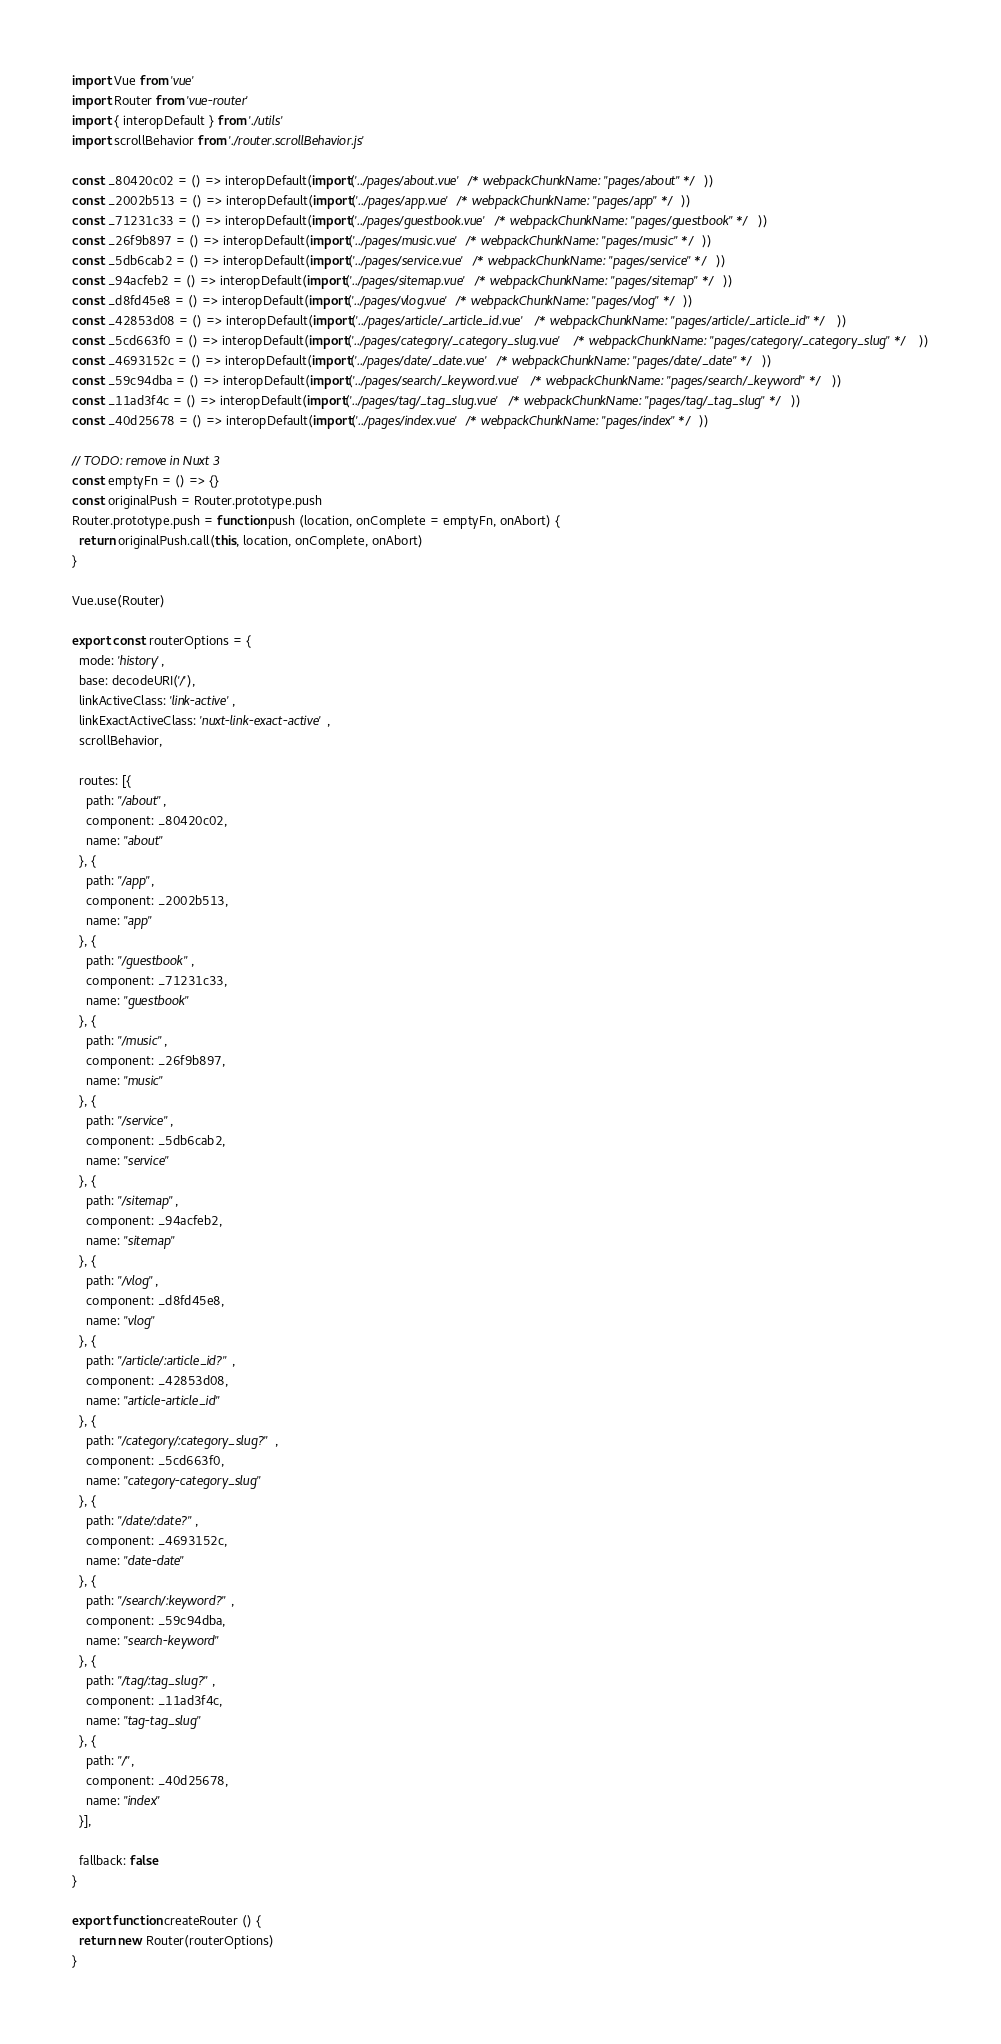Convert code to text. <code><loc_0><loc_0><loc_500><loc_500><_JavaScript_>import Vue from 'vue'
import Router from 'vue-router'
import { interopDefault } from './utils'
import scrollBehavior from './router.scrollBehavior.js'

const _80420c02 = () => interopDefault(import('../pages/about.vue' /* webpackChunkName: "pages/about" */))
const _2002b513 = () => interopDefault(import('../pages/app.vue' /* webpackChunkName: "pages/app" */))
const _71231c33 = () => interopDefault(import('../pages/guestbook.vue' /* webpackChunkName: "pages/guestbook" */))
const _26f9b897 = () => interopDefault(import('../pages/music.vue' /* webpackChunkName: "pages/music" */))
const _5db6cab2 = () => interopDefault(import('../pages/service.vue' /* webpackChunkName: "pages/service" */))
const _94acfeb2 = () => interopDefault(import('../pages/sitemap.vue' /* webpackChunkName: "pages/sitemap" */))
const _d8fd45e8 = () => interopDefault(import('../pages/vlog.vue' /* webpackChunkName: "pages/vlog" */))
const _42853d08 = () => interopDefault(import('../pages/article/_article_id.vue' /* webpackChunkName: "pages/article/_article_id" */))
const _5cd663f0 = () => interopDefault(import('../pages/category/_category_slug.vue' /* webpackChunkName: "pages/category/_category_slug" */))
const _4693152c = () => interopDefault(import('../pages/date/_date.vue' /* webpackChunkName: "pages/date/_date" */))
const _59c94dba = () => interopDefault(import('../pages/search/_keyword.vue' /* webpackChunkName: "pages/search/_keyword" */))
const _11ad3f4c = () => interopDefault(import('../pages/tag/_tag_slug.vue' /* webpackChunkName: "pages/tag/_tag_slug" */))
const _40d25678 = () => interopDefault(import('../pages/index.vue' /* webpackChunkName: "pages/index" */))

// TODO: remove in Nuxt 3
const emptyFn = () => {}
const originalPush = Router.prototype.push
Router.prototype.push = function push (location, onComplete = emptyFn, onAbort) {
  return originalPush.call(this, location, onComplete, onAbort)
}

Vue.use(Router)

export const routerOptions = {
  mode: 'history',
  base: decodeURI('/'),
  linkActiveClass: 'link-active',
  linkExactActiveClass: 'nuxt-link-exact-active',
  scrollBehavior,

  routes: [{
    path: "/about",
    component: _80420c02,
    name: "about"
  }, {
    path: "/app",
    component: _2002b513,
    name: "app"
  }, {
    path: "/guestbook",
    component: _71231c33,
    name: "guestbook"
  }, {
    path: "/music",
    component: _26f9b897,
    name: "music"
  }, {
    path: "/service",
    component: _5db6cab2,
    name: "service"
  }, {
    path: "/sitemap",
    component: _94acfeb2,
    name: "sitemap"
  }, {
    path: "/vlog",
    component: _d8fd45e8,
    name: "vlog"
  }, {
    path: "/article/:article_id?",
    component: _42853d08,
    name: "article-article_id"
  }, {
    path: "/category/:category_slug?",
    component: _5cd663f0,
    name: "category-category_slug"
  }, {
    path: "/date/:date?",
    component: _4693152c,
    name: "date-date"
  }, {
    path: "/search/:keyword?",
    component: _59c94dba,
    name: "search-keyword"
  }, {
    path: "/tag/:tag_slug?",
    component: _11ad3f4c,
    name: "tag-tag_slug"
  }, {
    path: "/",
    component: _40d25678,
    name: "index"
  }],

  fallback: false
}

export function createRouter () {
  return new Router(routerOptions)
}
</code> 